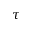Convert formula to latex. <formula><loc_0><loc_0><loc_500><loc_500>\tau</formula> 